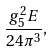Convert formula to latex. <formula><loc_0><loc_0><loc_500><loc_500>\frac { g _ { 5 } ^ { 2 } E } { 2 4 \pi ^ { 3 } } ,</formula> 